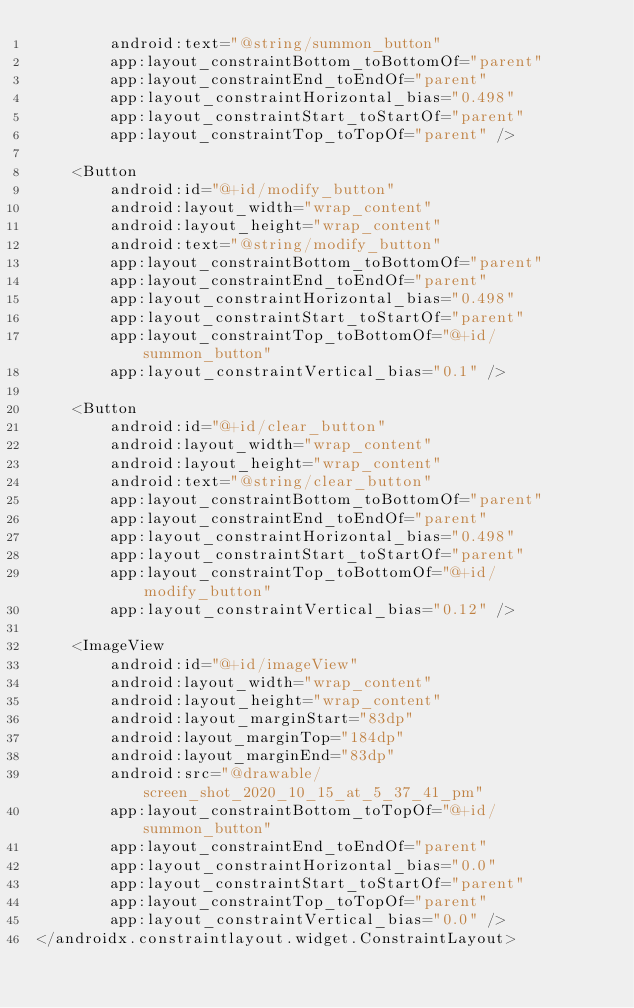<code> <loc_0><loc_0><loc_500><loc_500><_XML_>        android:text="@string/summon_button"
        app:layout_constraintBottom_toBottomOf="parent"
        app:layout_constraintEnd_toEndOf="parent"
        app:layout_constraintHorizontal_bias="0.498"
        app:layout_constraintStart_toStartOf="parent"
        app:layout_constraintTop_toTopOf="parent" />

    <Button
        android:id="@+id/modify_button"
        android:layout_width="wrap_content"
        android:layout_height="wrap_content"
        android:text="@string/modify_button"
        app:layout_constraintBottom_toBottomOf="parent"
        app:layout_constraintEnd_toEndOf="parent"
        app:layout_constraintHorizontal_bias="0.498"
        app:layout_constraintStart_toStartOf="parent"
        app:layout_constraintTop_toBottomOf="@+id/summon_button"
        app:layout_constraintVertical_bias="0.1" />

    <Button
        android:id="@+id/clear_button"
        android:layout_width="wrap_content"
        android:layout_height="wrap_content"
        android:text="@string/clear_button"
        app:layout_constraintBottom_toBottomOf="parent"
        app:layout_constraintEnd_toEndOf="parent"
        app:layout_constraintHorizontal_bias="0.498"
        app:layout_constraintStart_toStartOf="parent"
        app:layout_constraintTop_toBottomOf="@+id/modify_button"
        app:layout_constraintVertical_bias="0.12" />

    <ImageView
        android:id="@+id/imageView"
        android:layout_width="wrap_content"
        android:layout_height="wrap_content"
        android:layout_marginStart="83dp"
        android:layout_marginTop="184dp"
        android:layout_marginEnd="83dp"
        android:src="@drawable/screen_shot_2020_10_15_at_5_37_41_pm"
        app:layout_constraintBottom_toTopOf="@+id/summon_button"
        app:layout_constraintEnd_toEndOf="parent"
        app:layout_constraintHorizontal_bias="0.0"
        app:layout_constraintStart_toStartOf="parent"
        app:layout_constraintTop_toTopOf="parent"
        app:layout_constraintVertical_bias="0.0" />
</androidx.constraintlayout.widget.ConstraintLayout></code> 